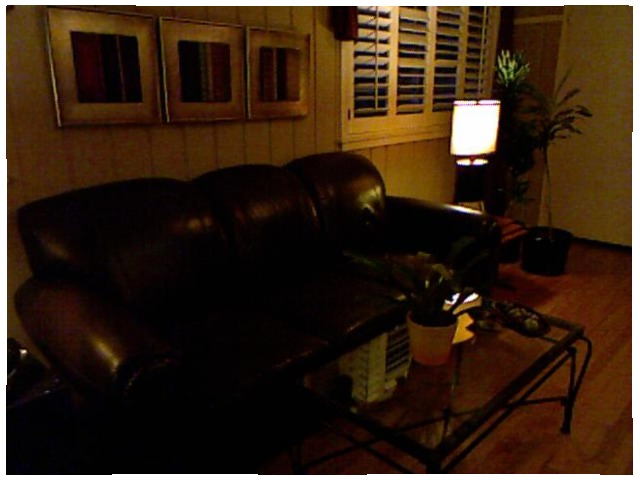<image>
Is there a chair on the table? No. The chair is not positioned on the table. They may be near each other, but the chair is not supported by or resting on top of the table. Where is the light lamp in relation to the sofa? Is it next to the sofa? Yes. The light lamp is positioned adjacent to the sofa, located nearby in the same general area. 